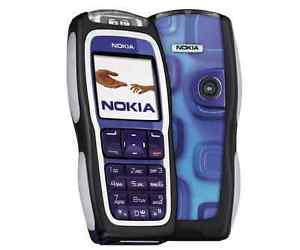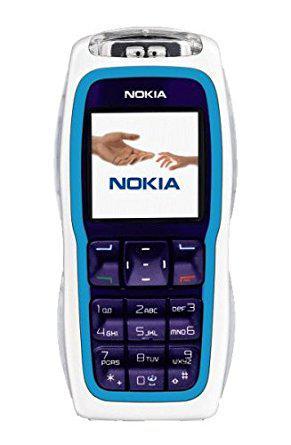The first image is the image on the left, the second image is the image on the right. Given the left and right images, does the statement "The right image contains a single phone displayed upright, and the left image shows one phone overlapping another one that is not in side-view." hold true? Answer yes or no. Yes. The first image is the image on the left, the second image is the image on the right. For the images shown, is this caption "Both pictures are showing only the front of at least two mobile phones." true? Answer yes or no. No. 